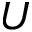Convert formula to latex. <formula><loc_0><loc_0><loc_500><loc_500>U</formula> 